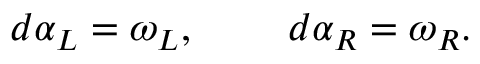<formula> <loc_0><loc_0><loc_500><loc_500>d \alpha _ { L } = \omega _ { L } , \, d \alpha _ { R } = \omega _ { R } .</formula> 